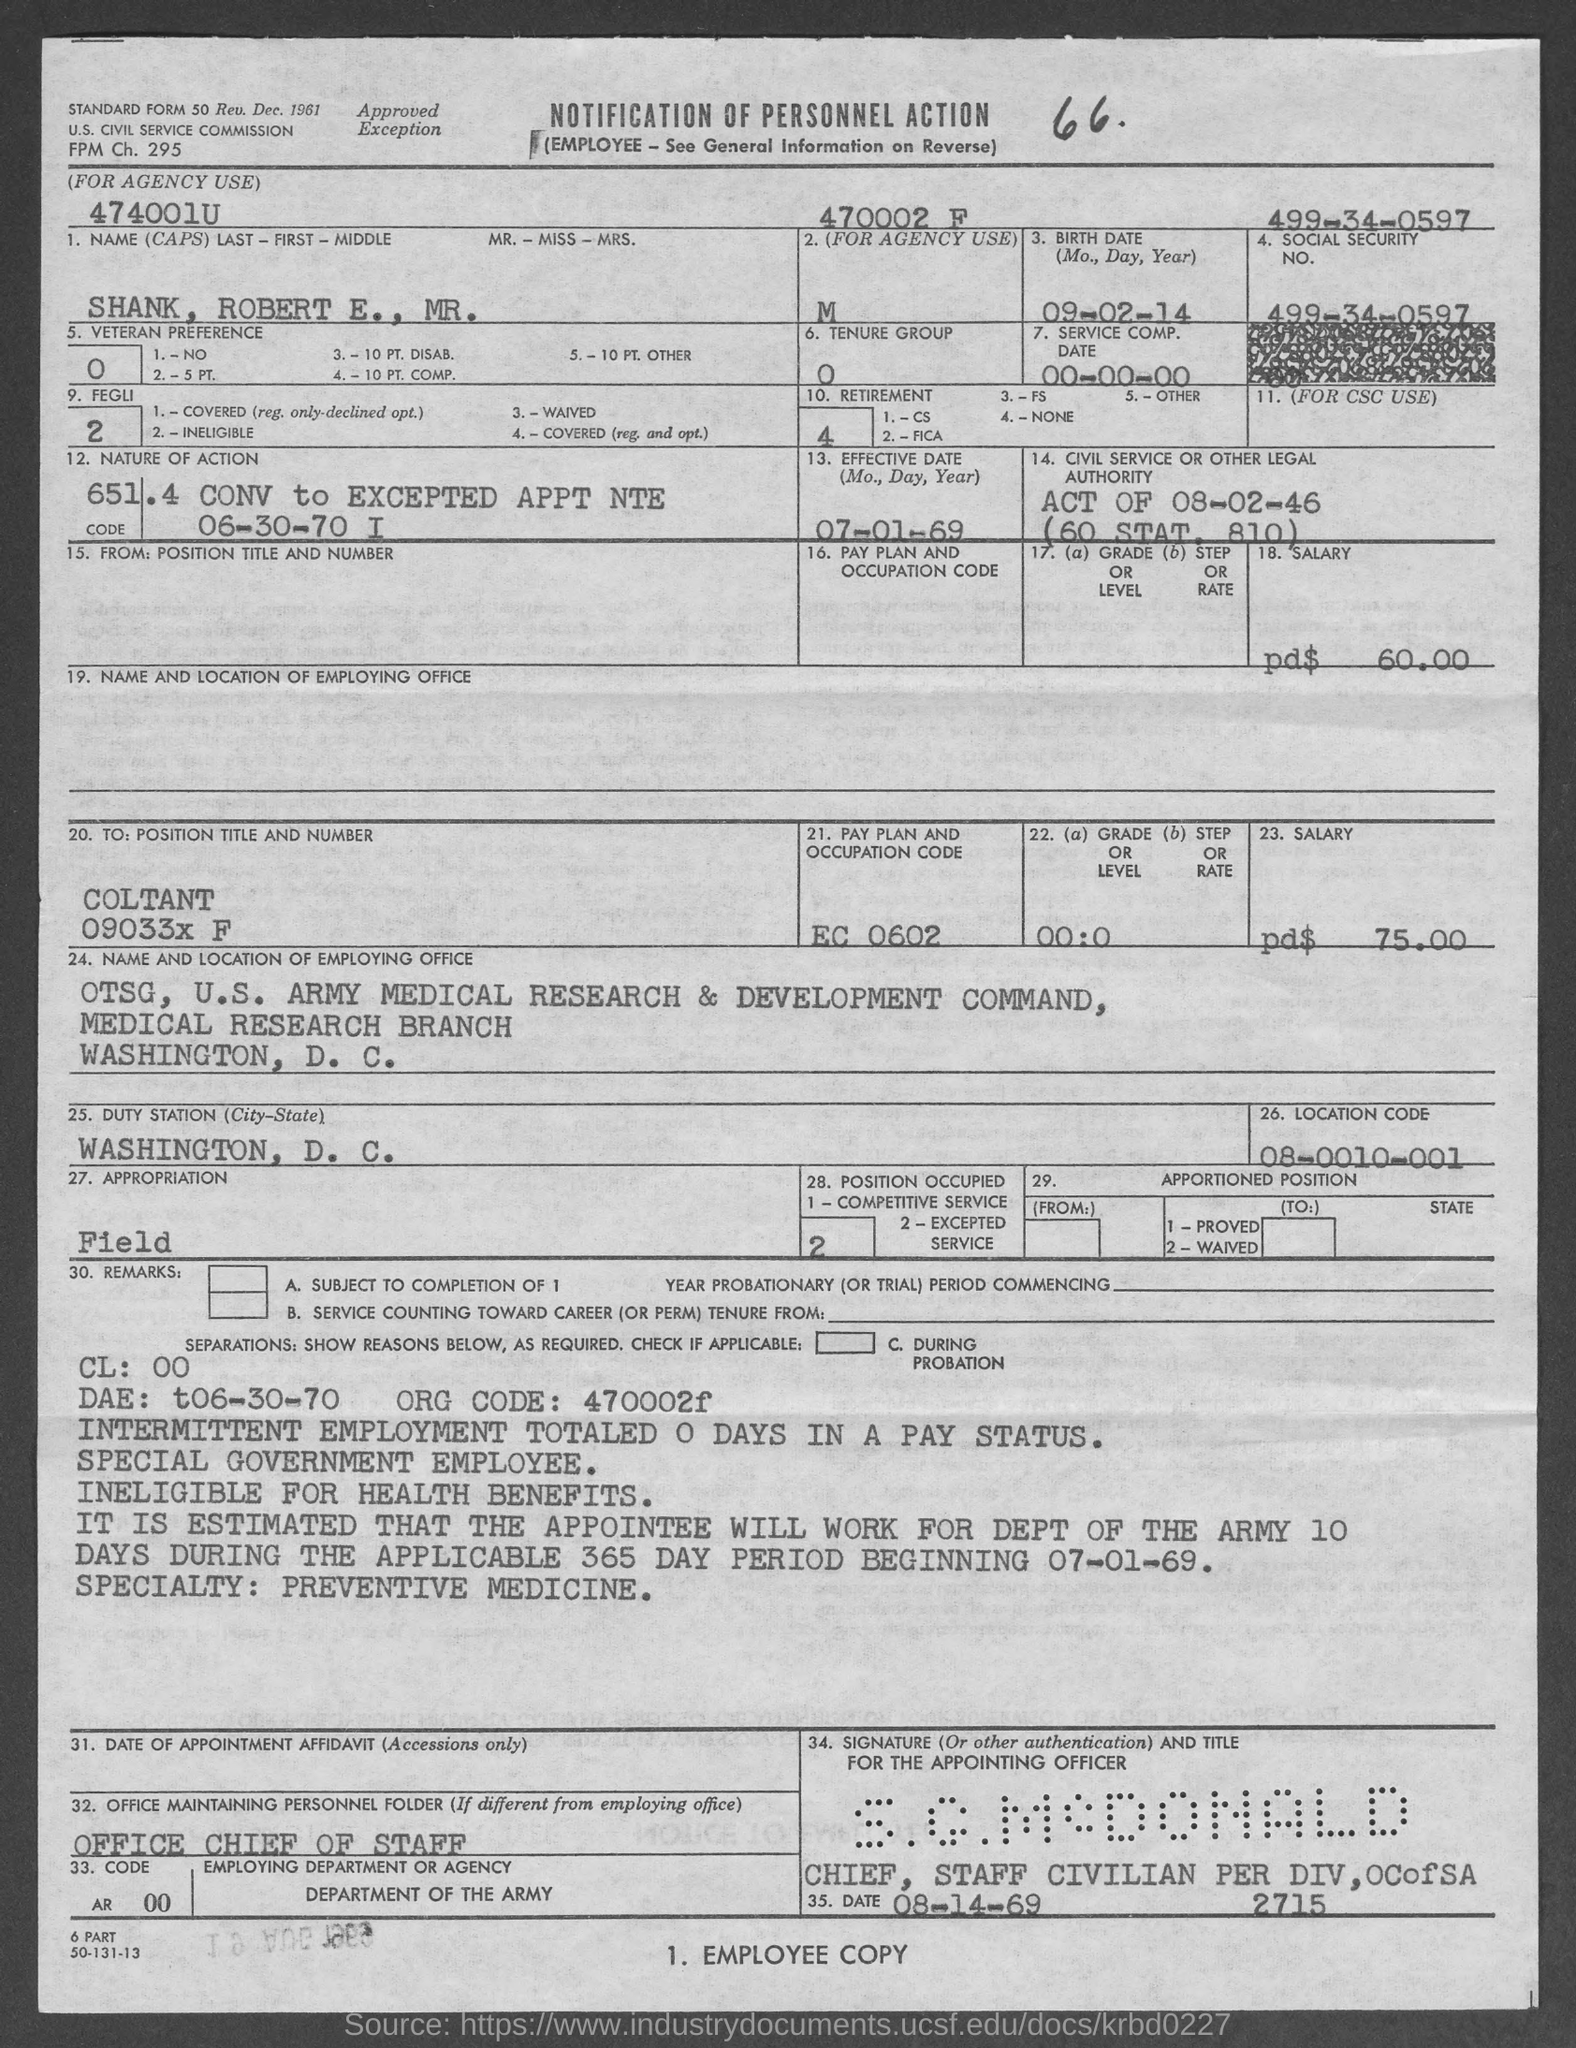What is social security no.?
Keep it short and to the point. 499-34-0597. What is the name of candidate ?
Your answer should be compact. Shank, Robert E., Mr. What is the pay plan and occupaton code ?
Give a very brief answer. EC 0602. What is the location code?
Offer a very short reply. 08-0010-001. 